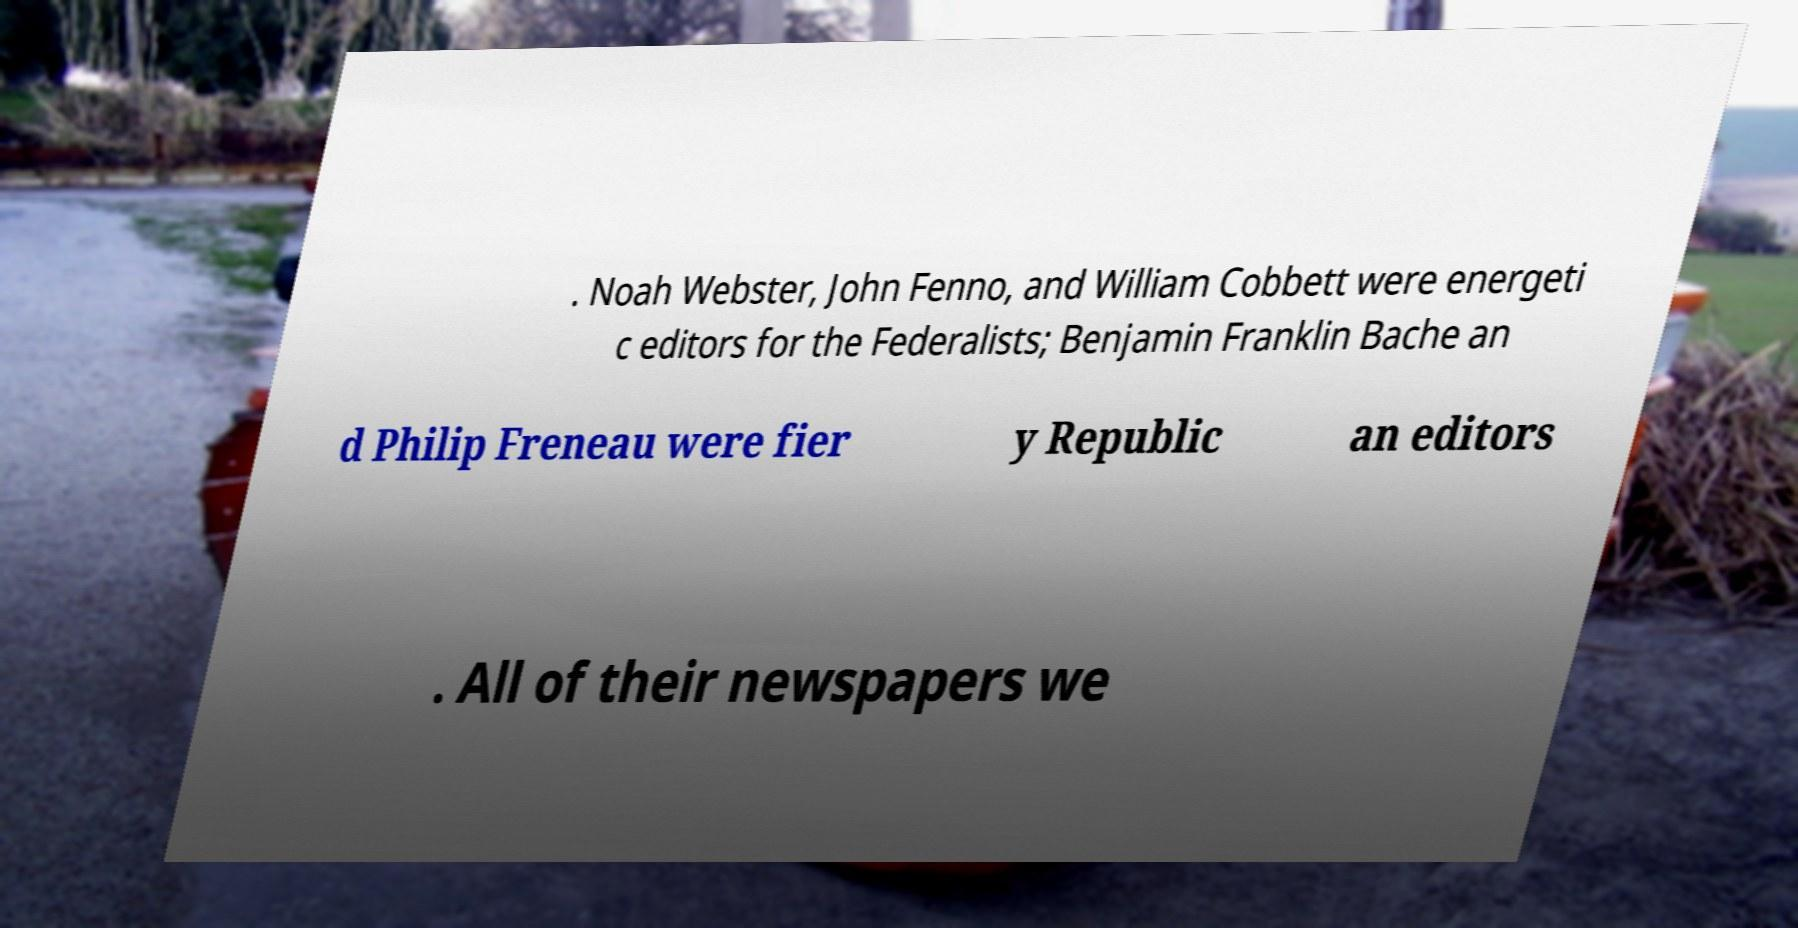Can you accurately transcribe the text from the provided image for me? . Noah Webster, John Fenno, and William Cobbett were energeti c editors for the Federalists; Benjamin Franklin Bache an d Philip Freneau were fier y Republic an editors . All of their newspapers we 